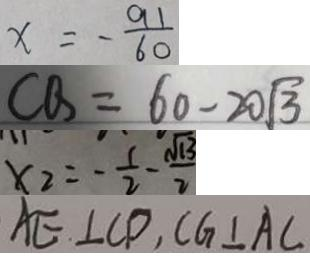Convert formula to latex. <formula><loc_0><loc_0><loc_500><loc_500>x = - \frac { 9 1 } { 6 0 } 
 C Q = 6 0 - 2 0 \sqrt { 3 } 
 x _ { 2 } = - \frac { 1 } { 2 } - \frac { \sqrt { 1 3 } } { 2 } 
 A E \bot C D , C G \bot A C</formula> 